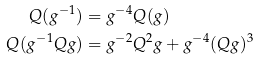Convert formula to latex. <formula><loc_0><loc_0><loc_500><loc_500>Q ( g ^ { - 1 } ) & = g ^ { - 4 } Q ( g ) \\ Q ( g ^ { - 1 } Q g ) & = g ^ { - 2 } Q ^ { 2 } g + g ^ { - 4 } ( Q g ) ^ { 3 }</formula> 